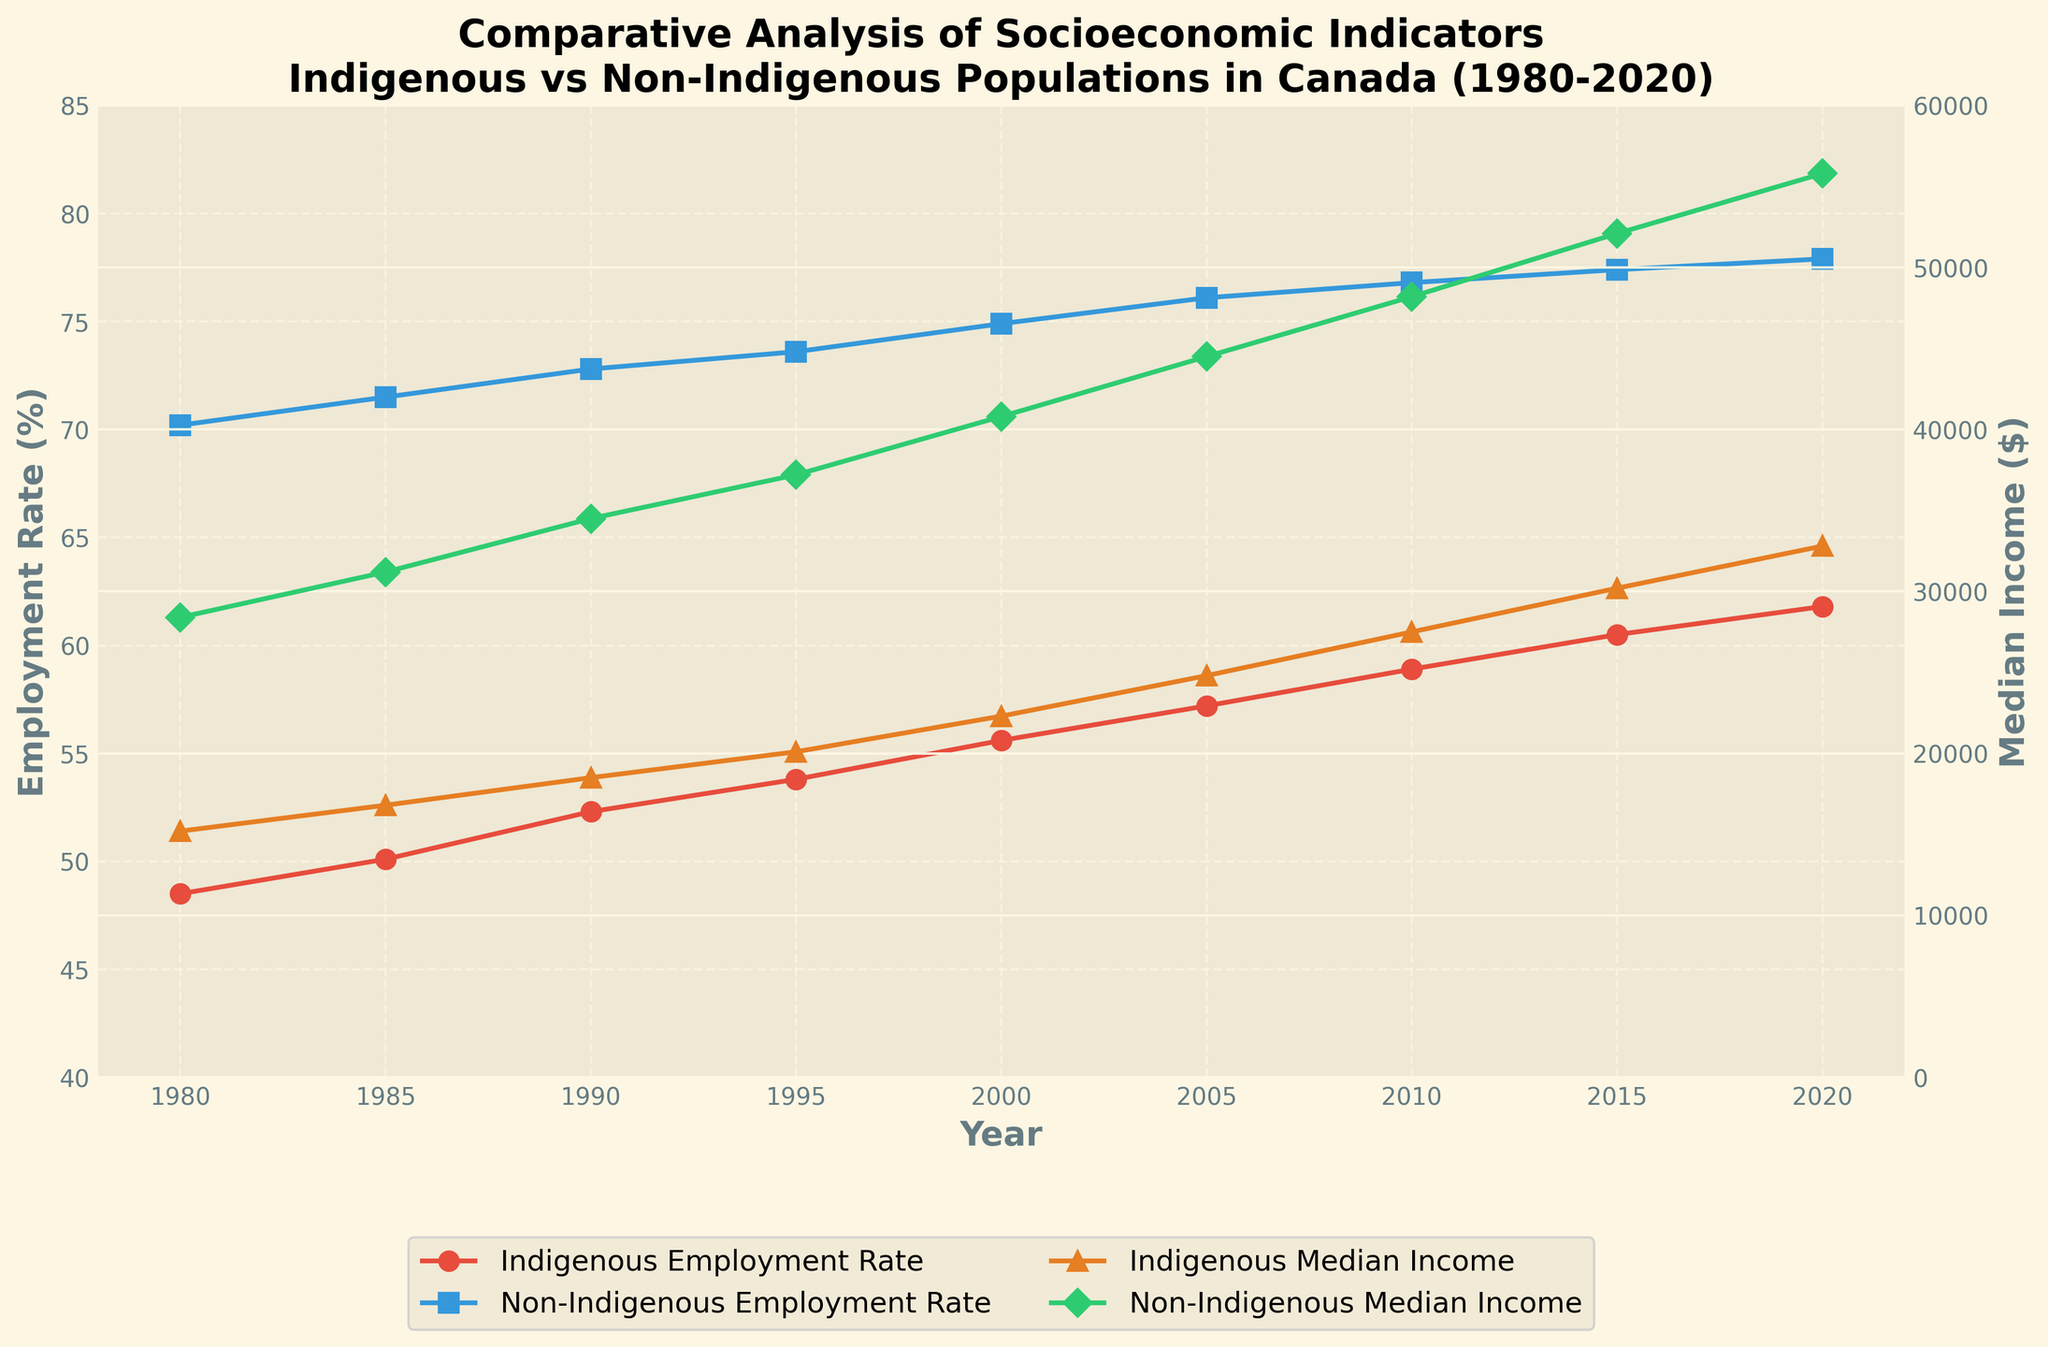What is the difference between Indigenous and Non-Indigenous Employment Rates in 1980? Locate the data points for the year 1980 on the Y-axis. The Employment Rate for Indigenous populations is 48.5%, and for Non-Indigenous populations, it is 70.2%. The difference is 70.2 - 48.5 = 21.7%.
Answer: 21.7% How much did the Indigenous Median Income increase from 1980 to 2020? Find the data points for Indigenous Median Income in 1980 and 2020. In 1980, it is $15,200, and in 2020, it is $32,800. The increase is 32,800 - 15,200 = 17,600.
Answer: 17,600 Which year shows the highest Post-Secondary Education rate for Indigenous populations? Look for the year with the highest value in the Indigenous Post-Secondary Education line (orange '+' markers). The highest value among those is 39.2% in 2020.
Answer: 2020 Are Indigenous populations' Employment Rates higher in 2000 or 2005? Compare the Employment Rate values for Indigenous populations in both years. For 2000, the rate is 55.6%, and for 2005, it is 57.2%. Therefore, it is higher in 2005.
Answer: 2005 By how much did the Non-Indigenous Median Income exceed the Indigenous Median Income in 2015? Find the Median Income points for both populations in 2015. For Indigenous populations, it is $30,200, and for Non-Indigenous populations, it is $52,100. The difference is 52,100 - 30,200 = 21,900.
Answer: 21,900 Comparing the two populations, in which years was the gap in Employment Rates the smallest? Observe the gap between the Employment Rate lines for each year. The smallest gap visually appears in 2020.
Answer: 2020 What is the average Indigenous Employment Rate across all years shown? Sum the Indigenous Employment Rates from 1980 to 2020 and divide by the number of years (9). The sum is 48.5 + 50.1 + 52.3 + 53.8 + 55.6 + 57.2 + 58.9 + 60.5 + 61.8 = 448.7. The average is 448.7 / 9 = 49.9.
Answer: 49.9 How did the gap in Post-Secondary Education between Indigenous and Non-Indigenous populations change from 1980 to 2020? Calculate the difference in Post-Secondary Education rates for both years: in 1980 (35.6 - 15.8 = 19.8) and in 2020 (62.4 - 39.2 = 23.2). Compare the values to see the change.
Answer: Increased by 3.4 In what year did the Indigenous Median Income first exceed $20,000? Check the Indigenous Median Income values year by year until it first exceeds $20,000. It first exceeds $20,000 in 1995 with a median income of $20,100.
Answer: 1995 